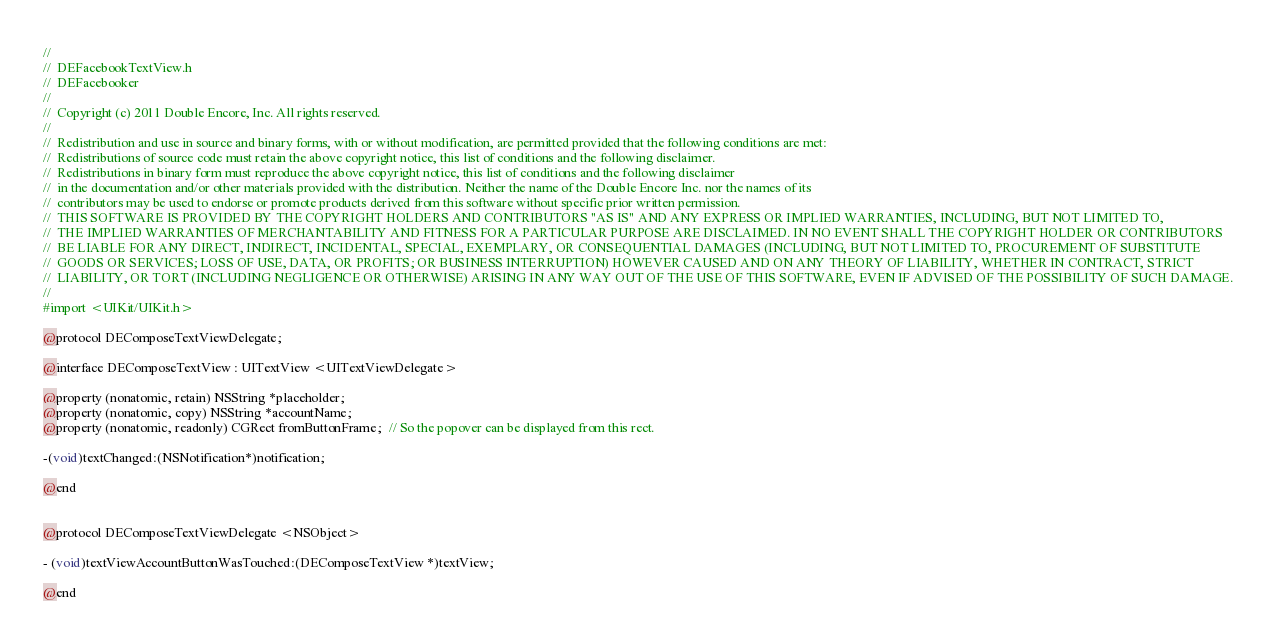Convert code to text. <code><loc_0><loc_0><loc_500><loc_500><_C_>//
//  DEFacebookTextView.h
//  DEFacebooker
//
//  Copyright (c) 2011 Double Encore, Inc. All rights reserved.
//
//  Redistribution and use in source and binary forms, with or without modification, are permitted provided that the following conditions are met:
//  Redistributions of source code must retain the above copyright notice, this list of conditions and the following disclaimer.
//  Redistributions in binary form must reproduce the above copyright notice, this list of conditions and the following disclaimer 
//  in the documentation and/or other materials provided with the distribution. Neither the name of the Double Encore Inc. nor the names of its 
//  contributors may be used to endorse or promote products derived from this software without specific prior written permission.
//  THIS SOFTWARE IS PROVIDED BY THE COPYRIGHT HOLDERS AND CONTRIBUTORS "AS IS" AND ANY EXPRESS OR IMPLIED WARRANTIES, INCLUDING, BUT NOT LIMITED TO, 
//  THE IMPLIED WARRANTIES OF MERCHANTABILITY AND FITNESS FOR A PARTICULAR PURPOSE ARE DISCLAIMED. IN NO EVENT SHALL THE COPYRIGHT HOLDER OR CONTRIBUTORS 
//  BE LIABLE FOR ANY DIRECT, INDIRECT, INCIDENTAL, SPECIAL, EXEMPLARY, OR CONSEQUENTIAL DAMAGES (INCLUDING, BUT NOT LIMITED TO, PROCUREMENT OF SUBSTITUTE 
//  GOODS OR SERVICES; LOSS OF USE, DATA, OR PROFITS; OR BUSINESS INTERRUPTION) HOWEVER CAUSED AND ON ANY THEORY OF LIABILITY, WHETHER IN CONTRACT, STRICT 
//  LIABILITY, OR TORT (INCLUDING NEGLIGENCE OR OTHERWISE) ARISING IN ANY WAY OUT OF THE USE OF THIS SOFTWARE, EVEN IF ADVISED OF THE POSSIBILITY OF SUCH DAMAGE.
//
#import <UIKit/UIKit.h>

@protocol DEComposeTextViewDelegate;

@interface DEComposeTextView : UITextView <UITextViewDelegate>

@property (nonatomic, retain) NSString *placeholder;
@property (nonatomic, copy) NSString *accountName;
@property (nonatomic, readonly) CGRect fromButtonFrame;  // So the popover can be displayed from this rect.

-(void)textChanged:(NSNotification*)notification;

@end


@protocol DEComposeTextViewDelegate <NSObject>

- (void)textViewAccountButtonWasTouched:(DEComposeTextView *)textView;

@end</code> 